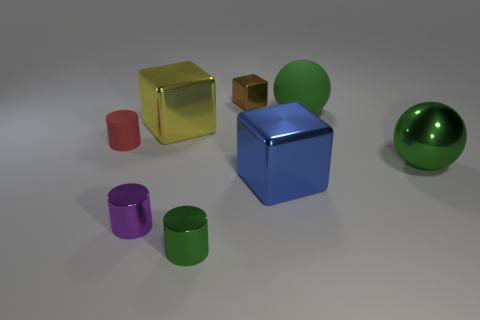How many blue shiny cubes are right of the small metal cylinder that is right of the yellow object?
Offer a terse response. 1. How many cubes are both in front of the yellow metal block and behind the tiny rubber thing?
Your response must be concise. 0. What number of other objects are the same material as the tiny red cylinder?
Keep it short and to the point. 1. There is a rubber thing that is on the left side of the green shiny object in front of the purple shiny object; what color is it?
Give a very brief answer. Red. There is a large thing behind the yellow cube; is it the same color as the large shiny sphere?
Offer a very short reply. Yes. Is the size of the red rubber thing the same as the blue block?
Provide a short and direct response. No. The matte object that is the same size as the purple cylinder is what shape?
Give a very brief answer. Cylinder. Is the size of the cube that is behind the yellow shiny object the same as the green matte ball?
Your response must be concise. No. What is the material of the red cylinder that is the same size as the brown metal object?
Make the answer very short. Rubber. Are there any blocks in front of the small brown shiny object left of the green sphere that is in front of the green matte object?
Offer a terse response. Yes. 